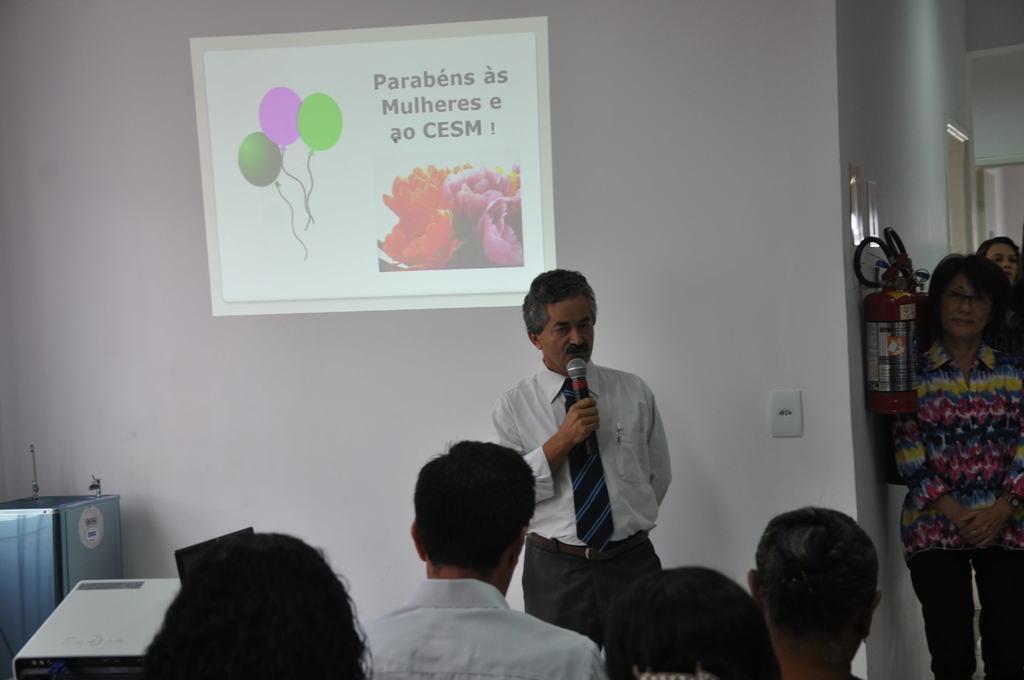In one or two sentences, can you explain what this image depicts? The picture is clicked inside a room. There are few people inside the room. In the background there on a screen there is a image of balloons and flowers. A person is talking something. He is holding a mic. In the right there is a lady. On the wall there is fire extinguisher. In the left there are two machines. In the foreground few people are there. 